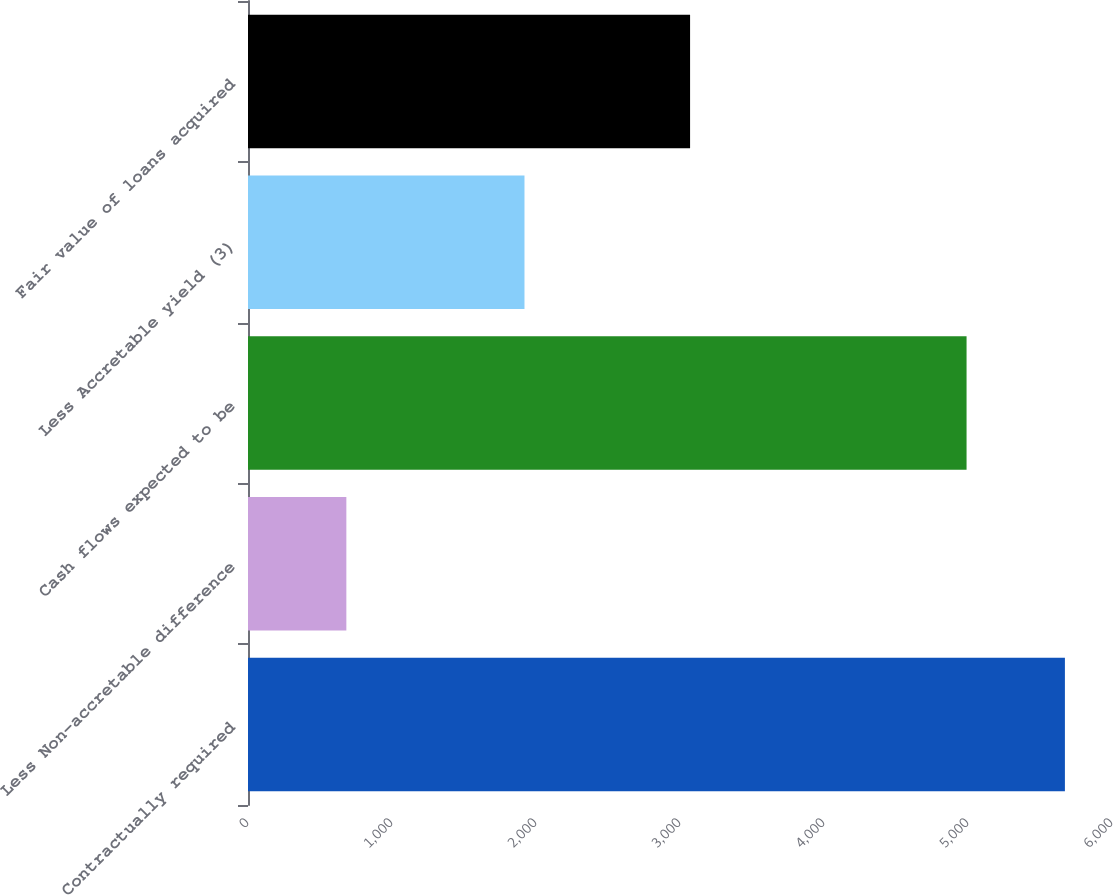Convert chart to OTSL. <chart><loc_0><loc_0><loc_500><loc_500><bar_chart><fcel>Contractually required<fcel>Less Non-accretable difference<fcel>Cash flows expected to be<fcel>Less Accretable yield (3)<fcel>Fair value of loans acquired<nl><fcel>5673<fcel>683<fcel>4990<fcel>1920<fcel>3070<nl></chart> 